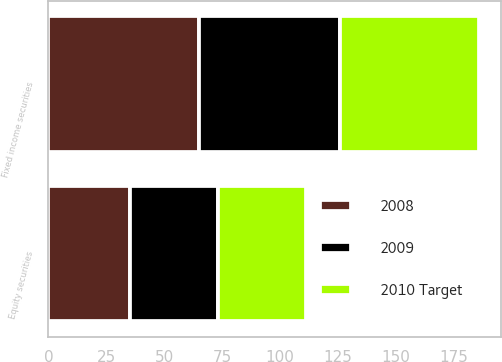Convert chart to OTSL. <chart><loc_0><loc_0><loc_500><loc_500><stacked_bar_chart><ecel><fcel>Equity securities<fcel>Fixed income securities<nl><fcel>2008<fcel>35<fcel>65<nl><fcel>2010 Target<fcel>38<fcel>60<nl><fcel>2009<fcel>38<fcel>60.9<nl></chart> 